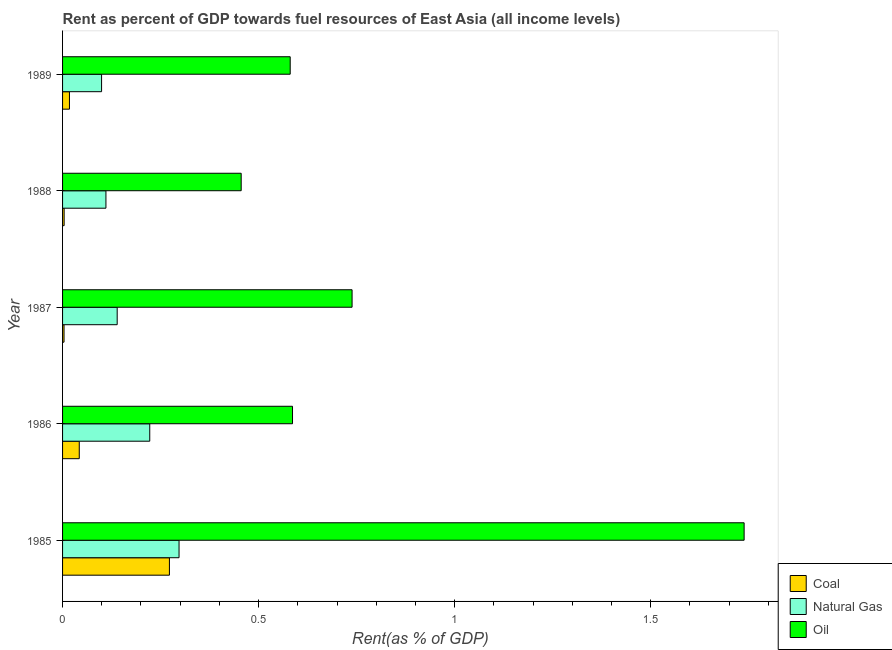How many different coloured bars are there?
Your answer should be compact. 3. How many groups of bars are there?
Offer a very short reply. 5. Are the number of bars per tick equal to the number of legend labels?
Your answer should be very brief. Yes. How many bars are there on the 1st tick from the bottom?
Give a very brief answer. 3. What is the label of the 4th group of bars from the top?
Give a very brief answer. 1986. What is the rent towards oil in 1987?
Offer a terse response. 0.74. Across all years, what is the maximum rent towards natural gas?
Your answer should be very brief. 0.3. Across all years, what is the minimum rent towards oil?
Your answer should be very brief. 0.46. In which year was the rent towards oil minimum?
Make the answer very short. 1988. What is the total rent towards oil in the graph?
Provide a short and direct response. 4.1. What is the difference between the rent towards coal in 1988 and that in 1989?
Ensure brevity in your answer.  -0.01. What is the difference between the rent towards oil in 1989 and the rent towards natural gas in 1985?
Ensure brevity in your answer.  0.28. What is the average rent towards natural gas per year?
Offer a very short reply. 0.17. In the year 1989, what is the difference between the rent towards natural gas and rent towards oil?
Offer a terse response. -0.48. What is the ratio of the rent towards natural gas in 1985 to that in 1986?
Offer a terse response. 1.34. Is the rent towards natural gas in 1986 less than that in 1989?
Keep it short and to the point. No. Is the difference between the rent towards oil in 1987 and 1989 greater than the difference between the rent towards natural gas in 1987 and 1989?
Offer a very short reply. Yes. What is the difference between the highest and the second highest rent towards oil?
Keep it short and to the point. 1. What is the difference between the highest and the lowest rent towards coal?
Give a very brief answer. 0.27. In how many years, is the rent towards oil greater than the average rent towards oil taken over all years?
Your response must be concise. 1. What does the 1st bar from the top in 1988 represents?
Provide a succinct answer. Oil. What does the 3rd bar from the bottom in 1987 represents?
Give a very brief answer. Oil. Is it the case that in every year, the sum of the rent towards coal and rent towards natural gas is greater than the rent towards oil?
Your answer should be compact. No. What is the difference between two consecutive major ticks on the X-axis?
Ensure brevity in your answer.  0.5. Are the values on the major ticks of X-axis written in scientific E-notation?
Provide a short and direct response. No. Does the graph contain any zero values?
Your response must be concise. No. How are the legend labels stacked?
Make the answer very short. Vertical. What is the title of the graph?
Provide a short and direct response. Rent as percent of GDP towards fuel resources of East Asia (all income levels). What is the label or title of the X-axis?
Offer a terse response. Rent(as % of GDP). What is the Rent(as % of GDP) in Coal in 1985?
Your answer should be compact. 0.27. What is the Rent(as % of GDP) of Natural Gas in 1985?
Provide a short and direct response. 0.3. What is the Rent(as % of GDP) of Oil in 1985?
Your answer should be very brief. 1.74. What is the Rent(as % of GDP) of Coal in 1986?
Give a very brief answer. 0.04. What is the Rent(as % of GDP) in Natural Gas in 1986?
Offer a terse response. 0.22. What is the Rent(as % of GDP) in Oil in 1986?
Your answer should be very brief. 0.59. What is the Rent(as % of GDP) in Coal in 1987?
Give a very brief answer. 0. What is the Rent(as % of GDP) in Natural Gas in 1987?
Your answer should be very brief. 0.14. What is the Rent(as % of GDP) in Oil in 1987?
Keep it short and to the point. 0.74. What is the Rent(as % of GDP) in Coal in 1988?
Offer a terse response. 0. What is the Rent(as % of GDP) in Natural Gas in 1988?
Make the answer very short. 0.11. What is the Rent(as % of GDP) of Oil in 1988?
Keep it short and to the point. 0.46. What is the Rent(as % of GDP) in Coal in 1989?
Offer a very short reply. 0.02. What is the Rent(as % of GDP) in Natural Gas in 1989?
Give a very brief answer. 0.1. What is the Rent(as % of GDP) in Oil in 1989?
Make the answer very short. 0.58. Across all years, what is the maximum Rent(as % of GDP) of Coal?
Ensure brevity in your answer.  0.27. Across all years, what is the maximum Rent(as % of GDP) in Natural Gas?
Your answer should be very brief. 0.3. Across all years, what is the maximum Rent(as % of GDP) of Oil?
Your answer should be compact. 1.74. Across all years, what is the minimum Rent(as % of GDP) in Coal?
Give a very brief answer. 0. Across all years, what is the minimum Rent(as % of GDP) in Natural Gas?
Give a very brief answer. 0.1. Across all years, what is the minimum Rent(as % of GDP) of Oil?
Your answer should be compact. 0.46. What is the total Rent(as % of GDP) of Coal in the graph?
Provide a succinct answer. 0.34. What is the total Rent(as % of GDP) of Natural Gas in the graph?
Provide a succinct answer. 0.87. What is the total Rent(as % of GDP) in Oil in the graph?
Ensure brevity in your answer.  4.1. What is the difference between the Rent(as % of GDP) of Coal in 1985 and that in 1986?
Provide a short and direct response. 0.23. What is the difference between the Rent(as % of GDP) of Natural Gas in 1985 and that in 1986?
Your answer should be very brief. 0.07. What is the difference between the Rent(as % of GDP) of Oil in 1985 and that in 1986?
Keep it short and to the point. 1.15. What is the difference between the Rent(as % of GDP) in Coal in 1985 and that in 1987?
Give a very brief answer. 0.27. What is the difference between the Rent(as % of GDP) in Natural Gas in 1985 and that in 1987?
Provide a short and direct response. 0.16. What is the difference between the Rent(as % of GDP) in Oil in 1985 and that in 1987?
Provide a short and direct response. 1. What is the difference between the Rent(as % of GDP) of Coal in 1985 and that in 1988?
Provide a short and direct response. 0.27. What is the difference between the Rent(as % of GDP) in Natural Gas in 1985 and that in 1988?
Keep it short and to the point. 0.19. What is the difference between the Rent(as % of GDP) in Oil in 1985 and that in 1988?
Your response must be concise. 1.28. What is the difference between the Rent(as % of GDP) of Coal in 1985 and that in 1989?
Ensure brevity in your answer.  0.26. What is the difference between the Rent(as % of GDP) of Natural Gas in 1985 and that in 1989?
Your answer should be very brief. 0.2. What is the difference between the Rent(as % of GDP) in Oil in 1985 and that in 1989?
Your answer should be very brief. 1.16. What is the difference between the Rent(as % of GDP) of Coal in 1986 and that in 1987?
Provide a short and direct response. 0.04. What is the difference between the Rent(as % of GDP) of Natural Gas in 1986 and that in 1987?
Offer a very short reply. 0.08. What is the difference between the Rent(as % of GDP) of Oil in 1986 and that in 1987?
Offer a very short reply. -0.15. What is the difference between the Rent(as % of GDP) of Coal in 1986 and that in 1988?
Ensure brevity in your answer.  0.04. What is the difference between the Rent(as % of GDP) of Natural Gas in 1986 and that in 1988?
Keep it short and to the point. 0.11. What is the difference between the Rent(as % of GDP) of Oil in 1986 and that in 1988?
Your answer should be very brief. 0.13. What is the difference between the Rent(as % of GDP) of Coal in 1986 and that in 1989?
Keep it short and to the point. 0.03. What is the difference between the Rent(as % of GDP) in Natural Gas in 1986 and that in 1989?
Give a very brief answer. 0.12. What is the difference between the Rent(as % of GDP) in Oil in 1986 and that in 1989?
Ensure brevity in your answer.  0.01. What is the difference between the Rent(as % of GDP) in Coal in 1987 and that in 1988?
Keep it short and to the point. -0. What is the difference between the Rent(as % of GDP) in Natural Gas in 1987 and that in 1988?
Provide a succinct answer. 0.03. What is the difference between the Rent(as % of GDP) of Oil in 1987 and that in 1988?
Provide a short and direct response. 0.28. What is the difference between the Rent(as % of GDP) in Coal in 1987 and that in 1989?
Keep it short and to the point. -0.01. What is the difference between the Rent(as % of GDP) of Natural Gas in 1987 and that in 1989?
Keep it short and to the point. 0.04. What is the difference between the Rent(as % of GDP) of Oil in 1987 and that in 1989?
Provide a succinct answer. 0.16. What is the difference between the Rent(as % of GDP) in Coal in 1988 and that in 1989?
Provide a short and direct response. -0.01. What is the difference between the Rent(as % of GDP) in Natural Gas in 1988 and that in 1989?
Your answer should be compact. 0.01. What is the difference between the Rent(as % of GDP) of Oil in 1988 and that in 1989?
Make the answer very short. -0.12. What is the difference between the Rent(as % of GDP) of Coal in 1985 and the Rent(as % of GDP) of Natural Gas in 1986?
Your answer should be very brief. 0.05. What is the difference between the Rent(as % of GDP) of Coal in 1985 and the Rent(as % of GDP) of Oil in 1986?
Give a very brief answer. -0.31. What is the difference between the Rent(as % of GDP) of Natural Gas in 1985 and the Rent(as % of GDP) of Oil in 1986?
Make the answer very short. -0.29. What is the difference between the Rent(as % of GDP) of Coal in 1985 and the Rent(as % of GDP) of Natural Gas in 1987?
Your answer should be compact. 0.13. What is the difference between the Rent(as % of GDP) of Coal in 1985 and the Rent(as % of GDP) of Oil in 1987?
Your answer should be compact. -0.47. What is the difference between the Rent(as % of GDP) in Natural Gas in 1985 and the Rent(as % of GDP) in Oil in 1987?
Give a very brief answer. -0.44. What is the difference between the Rent(as % of GDP) in Coal in 1985 and the Rent(as % of GDP) in Natural Gas in 1988?
Provide a short and direct response. 0.16. What is the difference between the Rent(as % of GDP) in Coal in 1985 and the Rent(as % of GDP) in Oil in 1988?
Keep it short and to the point. -0.18. What is the difference between the Rent(as % of GDP) in Natural Gas in 1985 and the Rent(as % of GDP) in Oil in 1988?
Provide a succinct answer. -0.16. What is the difference between the Rent(as % of GDP) in Coal in 1985 and the Rent(as % of GDP) in Natural Gas in 1989?
Offer a very short reply. 0.17. What is the difference between the Rent(as % of GDP) of Coal in 1985 and the Rent(as % of GDP) of Oil in 1989?
Keep it short and to the point. -0.31. What is the difference between the Rent(as % of GDP) in Natural Gas in 1985 and the Rent(as % of GDP) in Oil in 1989?
Your answer should be very brief. -0.28. What is the difference between the Rent(as % of GDP) in Coal in 1986 and the Rent(as % of GDP) in Natural Gas in 1987?
Your response must be concise. -0.1. What is the difference between the Rent(as % of GDP) of Coal in 1986 and the Rent(as % of GDP) of Oil in 1987?
Give a very brief answer. -0.7. What is the difference between the Rent(as % of GDP) of Natural Gas in 1986 and the Rent(as % of GDP) of Oil in 1987?
Your answer should be very brief. -0.52. What is the difference between the Rent(as % of GDP) in Coal in 1986 and the Rent(as % of GDP) in Natural Gas in 1988?
Ensure brevity in your answer.  -0.07. What is the difference between the Rent(as % of GDP) of Coal in 1986 and the Rent(as % of GDP) of Oil in 1988?
Offer a terse response. -0.41. What is the difference between the Rent(as % of GDP) of Natural Gas in 1986 and the Rent(as % of GDP) of Oil in 1988?
Offer a very short reply. -0.23. What is the difference between the Rent(as % of GDP) of Coal in 1986 and the Rent(as % of GDP) of Natural Gas in 1989?
Your response must be concise. -0.06. What is the difference between the Rent(as % of GDP) in Coal in 1986 and the Rent(as % of GDP) in Oil in 1989?
Provide a succinct answer. -0.54. What is the difference between the Rent(as % of GDP) in Natural Gas in 1986 and the Rent(as % of GDP) in Oil in 1989?
Keep it short and to the point. -0.36. What is the difference between the Rent(as % of GDP) of Coal in 1987 and the Rent(as % of GDP) of Natural Gas in 1988?
Your answer should be very brief. -0.11. What is the difference between the Rent(as % of GDP) of Coal in 1987 and the Rent(as % of GDP) of Oil in 1988?
Your answer should be compact. -0.45. What is the difference between the Rent(as % of GDP) in Natural Gas in 1987 and the Rent(as % of GDP) in Oil in 1988?
Your answer should be very brief. -0.32. What is the difference between the Rent(as % of GDP) of Coal in 1987 and the Rent(as % of GDP) of Natural Gas in 1989?
Ensure brevity in your answer.  -0.1. What is the difference between the Rent(as % of GDP) in Coal in 1987 and the Rent(as % of GDP) in Oil in 1989?
Provide a short and direct response. -0.58. What is the difference between the Rent(as % of GDP) in Natural Gas in 1987 and the Rent(as % of GDP) in Oil in 1989?
Provide a succinct answer. -0.44. What is the difference between the Rent(as % of GDP) of Coal in 1988 and the Rent(as % of GDP) of Natural Gas in 1989?
Your answer should be compact. -0.1. What is the difference between the Rent(as % of GDP) in Coal in 1988 and the Rent(as % of GDP) in Oil in 1989?
Give a very brief answer. -0.58. What is the difference between the Rent(as % of GDP) in Natural Gas in 1988 and the Rent(as % of GDP) in Oil in 1989?
Provide a succinct answer. -0.47. What is the average Rent(as % of GDP) of Coal per year?
Keep it short and to the point. 0.07. What is the average Rent(as % of GDP) of Natural Gas per year?
Give a very brief answer. 0.17. What is the average Rent(as % of GDP) in Oil per year?
Offer a very short reply. 0.82. In the year 1985, what is the difference between the Rent(as % of GDP) of Coal and Rent(as % of GDP) of Natural Gas?
Your answer should be compact. -0.02. In the year 1985, what is the difference between the Rent(as % of GDP) in Coal and Rent(as % of GDP) in Oil?
Offer a very short reply. -1.47. In the year 1985, what is the difference between the Rent(as % of GDP) of Natural Gas and Rent(as % of GDP) of Oil?
Offer a very short reply. -1.44. In the year 1986, what is the difference between the Rent(as % of GDP) in Coal and Rent(as % of GDP) in Natural Gas?
Your response must be concise. -0.18. In the year 1986, what is the difference between the Rent(as % of GDP) in Coal and Rent(as % of GDP) in Oil?
Your answer should be very brief. -0.54. In the year 1986, what is the difference between the Rent(as % of GDP) of Natural Gas and Rent(as % of GDP) of Oil?
Offer a very short reply. -0.36. In the year 1987, what is the difference between the Rent(as % of GDP) of Coal and Rent(as % of GDP) of Natural Gas?
Make the answer very short. -0.14. In the year 1987, what is the difference between the Rent(as % of GDP) of Coal and Rent(as % of GDP) of Oil?
Your answer should be very brief. -0.73. In the year 1987, what is the difference between the Rent(as % of GDP) in Natural Gas and Rent(as % of GDP) in Oil?
Offer a terse response. -0.6. In the year 1988, what is the difference between the Rent(as % of GDP) in Coal and Rent(as % of GDP) in Natural Gas?
Provide a succinct answer. -0.11. In the year 1988, what is the difference between the Rent(as % of GDP) in Coal and Rent(as % of GDP) in Oil?
Your answer should be very brief. -0.45. In the year 1988, what is the difference between the Rent(as % of GDP) in Natural Gas and Rent(as % of GDP) in Oil?
Make the answer very short. -0.34. In the year 1989, what is the difference between the Rent(as % of GDP) of Coal and Rent(as % of GDP) of Natural Gas?
Ensure brevity in your answer.  -0.08. In the year 1989, what is the difference between the Rent(as % of GDP) in Coal and Rent(as % of GDP) in Oil?
Keep it short and to the point. -0.56. In the year 1989, what is the difference between the Rent(as % of GDP) in Natural Gas and Rent(as % of GDP) in Oil?
Offer a terse response. -0.48. What is the ratio of the Rent(as % of GDP) in Coal in 1985 to that in 1986?
Make the answer very short. 6.4. What is the ratio of the Rent(as % of GDP) in Natural Gas in 1985 to that in 1986?
Your response must be concise. 1.34. What is the ratio of the Rent(as % of GDP) of Oil in 1985 to that in 1986?
Make the answer very short. 2.96. What is the ratio of the Rent(as % of GDP) of Coal in 1985 to that in 1987?
Provide a short and direct response. 73. What is the ratio of the Rent(as % of GDP) of Natural Gas in 1985 to that in 1987?
Make the answer very short. 2.13. What is the ratio of the Rent(as % of GDP) in Oil in 1985 to that in 1987?
Give a very brief answer. 2.35. What is the ratio of the Rent(as % of GDP) of Coal in 1985 to that in 1988?
Your answer should be compact. 67.7. What is the ratio of the Rent(as % of GDP) in Natural Gas in 1985 to that in 1988?
Provide a succinct answer. 2.69. What is the ratio of the Rent(as % of GDP) of Oil in 1985 to that in 1988?
Your answer should be compact. 3.82. What is the ratio of the Rent(as % of GDP) of Coal in 1985 to that in 1989?
Your response must be concise. 15.53. What is the ratio of the Rent(as % of GDP) in Natural Gas in 1985 to that in 1989?
Your answer should be compact. 2.99. What is the ratio of the Rent(as % of GDP) of Oil in 1985 to that in 1989?
Your answer should be very brief. 2.99. What is the ratio of the Rent(as % of GDP) of Coal in 1986 to that in 1987?
Keep it short and to the point. 11.4. What is the ratio of the Rent(as % of GDP) of Natural Gas in 1986 to that in 1987?
Give a very brief answer. 1.6. What is the ratio of the Rent(as % of GDP) of Oil in 1986 to that in 1987?
Offer a very short reply. 0.79. What is the ratio of the Rent(as % of GDP) in Coal in 1986 to that in 1988?
Provide a succinct answer. 10.58. What is the ratio of the Rent(as % of GDP) in Natural Gas in 1986 to that in 1988?
Give a very brief answer. 2.01. What is the ratio of the Rent(as % of GDP) in Oil in 1986 to that in 1988?
Offer a very short reply. 1.29. What is the ratio of the Rent(as % of GDP) in Coal in 1986 to that in 1989?
Provide a short and direct response. 2.43. What is the ratio of the Rent(as % of GDP) in Natural Gas in 1986 to that in 1989?
Your response must be concise. 2.23. What is the ratio of the Rent(as % of GDP) in Oil in 1986 to that in 1989?
Offer a terse response. 1.01. What is the ratio of the Rent(as % of GDP) in Coal in 1987 to that in 1988?
Provide a short and direct response. 0.93. What is the ratio of the Rent(as % of GDP) in Natural Gas in 1987 to that in 1988?
Keep it short and to the point. 1.26. What is the ratio of the Rent(as % of GDP) of Oil in 1987 to that in 1988?
Your response must be concise. 1.62. What is the ratio of the Rent(as % of GDP) in Coal in 1987 to that in 1989?
Give a very brief answer. 0.21. What is the ratio of the Rent(as % of GDP) in Natural Gas in 1987 to that in 1989?
Make the answer very short. 1.4. What is the ratio of the Rent(as % of GDP) of Oil in 1987 to that in 1989?
Offer a very short reply. 1.27. What is the ratio of the Rent(as % of GDP) of Coal in 1988 to that in 1989?
Your response must be concise. 0.23. What is the ratio of the Rent(as % of GDP) in Natural Gas in 1988 to that in 1989?
Provide a short and direct response. 1.11. What is the ratio of the Rent(as % of GDP) in Oil in 1988 to that in 1989?
Your answer should be compact. 0.78. What is the difference between the highest and the second highest Rent(as % of GDP) of Coal?
Offer a terse response. 0.23. What is the difference between the highest and the second highest Rent(as % of GDP) in Natural Gas?
Keep it short and to the point. 0.07. What is the difference between the highest and the lowest Rent(as % of GDP) in Coal?
Provide a succinct answer. 0.27. What is the difference between the highest and the lowest Rent(as % of GDP) in Natural Gas?
Provide a short and direct response. 0.2. What is the difference between the highest and the lowest Rent(as % of GDP) of Oil?
Your answer should be compact. 1.28. 